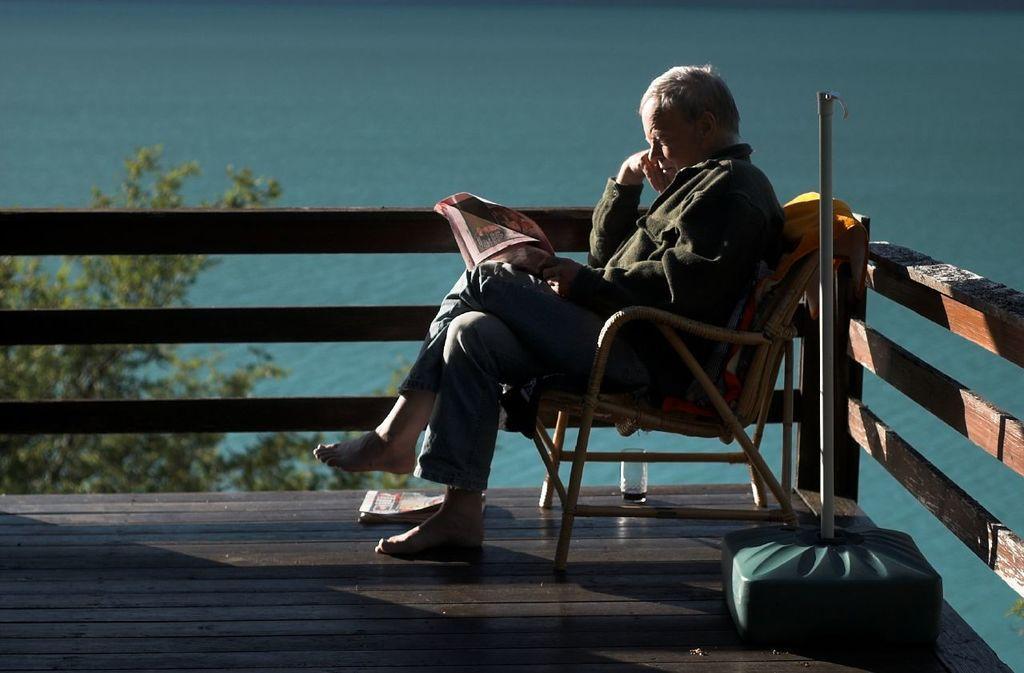Could you give a brief overview of what you see in this image? In this image we can see a man sitting on the chair and holding a book. At the bottom there is a deck and we can see a glass, book and an object placed on the deck. In the background there is water and we can see a tree. 